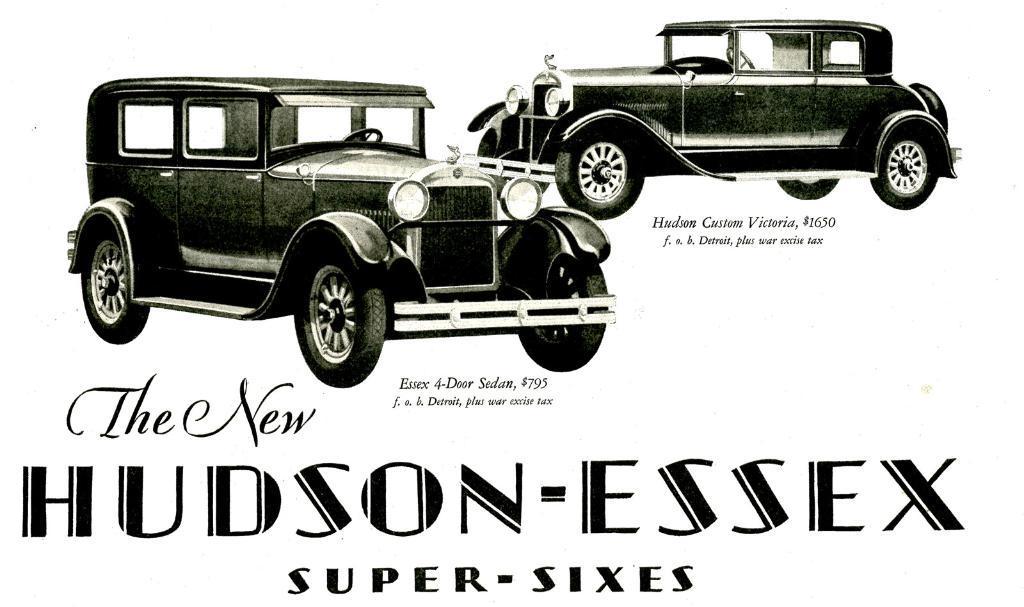Please provide a concise description of this image. In this image there is a picture of cars on the top of this image and there is some text written in the bottom of this image. 